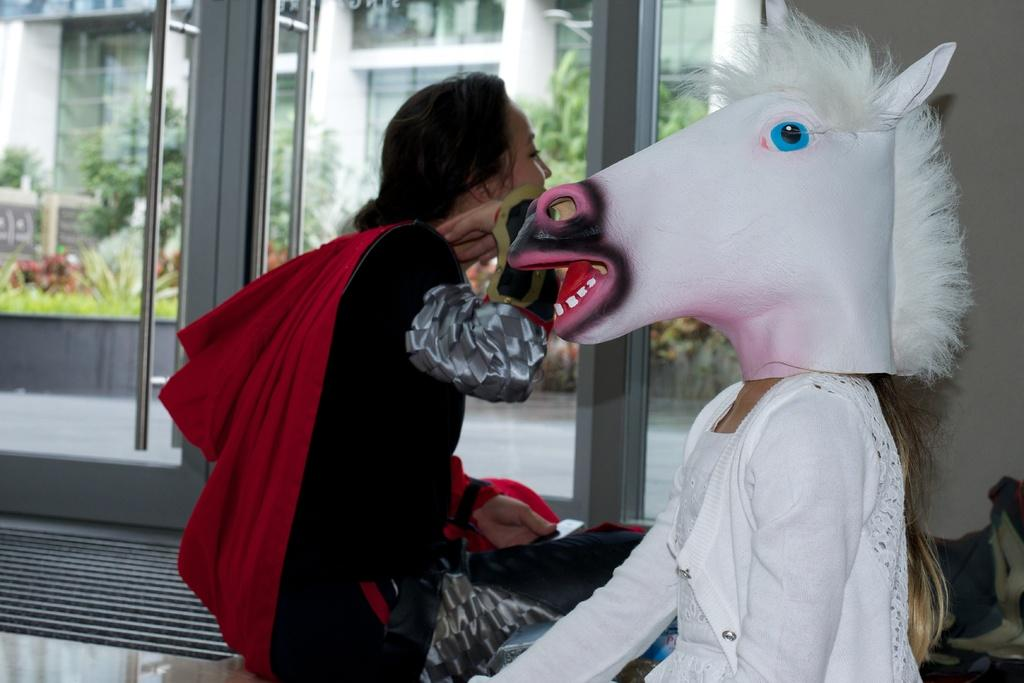How many people are present in the image? There are two persons sitting in the image. What is unique about the appearance of one of the persons? One person is wearing an animal head mask. What can be seen in the background of the image? There is a building, trees, plants, and a glass door in the background of the image. What type of sweater is the person wearing in the image? There is no sweater mentioned or visible in the image. Can you describe the pot that the person is holding in the image? There is no pot present in the image. 